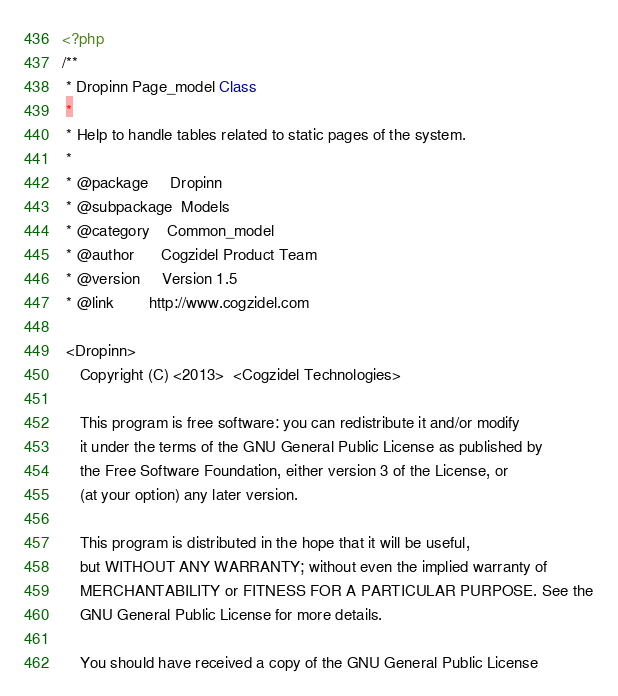Convert code to text. <code><loc_0><loc_0><loc_500><loc_500><_PHP_><?php
/**
 * Dropinn Page_model Class
 *
 * Help to handle tables related to static pages of the system.
 *
 * @package		Dropinn
 * @subpackage	Models
 * @category	Common_model 
 * @author		Cogzidel Product Team
 * @version		Version 1.5
 * @link		http://www.cogzidel.com
 
 <Dropinn> 
    Copyright (C) <2013>  <Cogzidel Technologies>

    This program is free software: you can redistribute it and/or modify
    it under the terms of the GNU General Public License as published by
    the Free Software Foundation, either version 3 of the License, or
    (at your option) any later version.

    This program is distributed in the hope that it will be useful,
    but WITHOUT ANY WARRANTY; without even the implied warranty of
    MERCHANTABILITY or FITNESS FOR A PARTICULAR PURPOSE. See the
    GNU General Public License for more details.

    You should have received a copy of the GNU General Public License</code> 